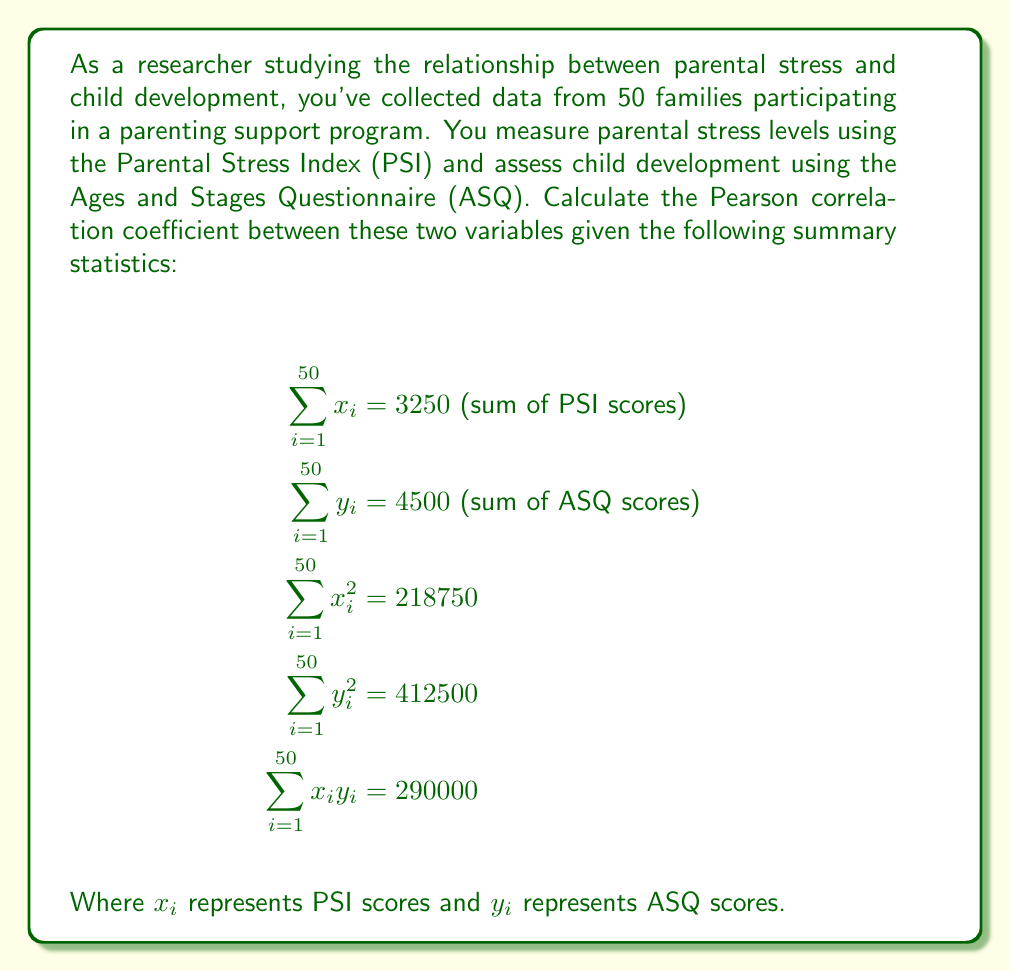Can you answer this question? To calculate the Pearson correlation coefficient, we'll use the formula:

$$r = \frac{n\sum x_iy_i - (\sum x_i)(\sum y_i)}{\sqrt{[n\sum x_i^2 - (\sum x_i)^2][n\sum y_i^2 - (\sum y_i)^2]}}$$

Where $n$ is the number of pairs (50 in this case).

Let's calculate each component:

1. $n\sum x_iy_i = 50 \times 290000 = 14500000$
2. $(\sum x_i)(\sum y_i) = 3250 \times 4500 = 14625000$
3. $n\sum x_i^2 = 50 \times 218750 = 10937500$
4. $(\sum x_i)^2 = 3250^2 = 10562500$
5. $n\sum y_i^2 = 50 \times 412500 = 20625000$
6. $(\sum y_i)^2 = 4500^2 = 20250000$

Now, let's substitute these values into the formula:

$$r = \frac{14500000 - 14625000}{\sqrt{(10937500 - 10562500)(20625000 - 20250000)}}$$

$$r = \frac{-125000}{\sqrt{(375000)(375000)}}$$

$$r = \frac{-125000}{375000}$$

$$r = -0.3333$$
Answer: $r \approx -0.33$ 